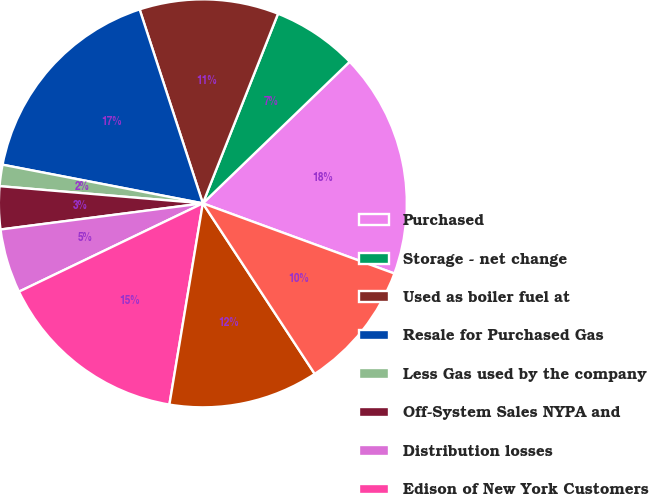<chart> <loc_0><loc_0><loc_500><loc_500><pie_chart><fcel>Purchased<fcel>Storage - net change<fcel>Used as boiler fuel at<fcel>Resale for Purchased Gas<fcel>Less Gas used by the company<fcel>Off-System Sales NYPA and<fcel>Distribution losses<fcel>Edison of New York Customers<fcel>Residential<fcel>General<nl><fcel>17.8%<fcel>6.78%<fcel>11.02%<fcel>16.95%<fcel>1.69%<fcel>3.39%<fcel>5.08%<fcel>15.25%<fcel>11.86%<fcel>10.17%<nl></chart> 